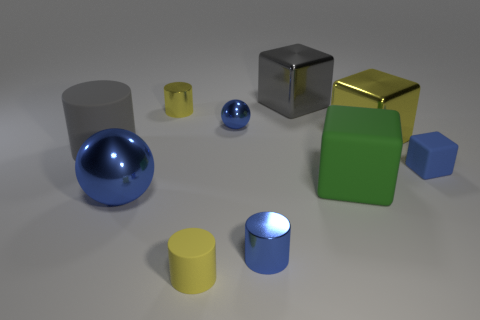What material is the blue sphere on the left side of the small blue metal ball?
Provide a succinct answer. Metal. Is the material of the tiny yellow cylinder behind the small yellow rubber thing the same as the green block?
Give a very brief answer. No. The yellow thing that is the same size as the yellow metal cylinder is what shape?
Offer a terse response. Cylinder. What number of rubber cubes are the same color as the small metallic sphere?
Give a very brief answer. 1. Is the number of tiny blue shiny spheres left of the big metallic ball less than the number of gray cylinders that are right of the gray rubber object?
Offer a very short reply. No. There is a tiny blue matte object; are there any blue objects to the left of it?
Your answer should be very brief. Yes. Is there a yellow thing in front of the yellow cylinder behind the large shiny ball that is to the left of the blue cylinder?
Offer a very short reply. Yes. There is a small matte thing that is to the right of the tiny blue cylinder; does it have the same shape as the big yellow object?
Offer a very short reply. Yes. There is a large thing that is the same material as the green block; what color is it?
Your answer should be very brief. Gray. How many other spheres have the same material as the small blue ball?
Provide a short and direct response. 1. 